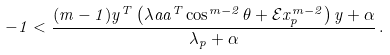<formula> <loc_0><loc_0><loc_500><loc_500>- 1 < \frac { ( m - 1 ) y ^ { T } \left ( \lambda a a ^ { T } \cos ^ { m - 2 } \theta + \mathcal { E } x _ { p } ^ { m - 2 } \right ) y + \alpha } { \lambda _ { p } + \alpha } \, .</formula> 